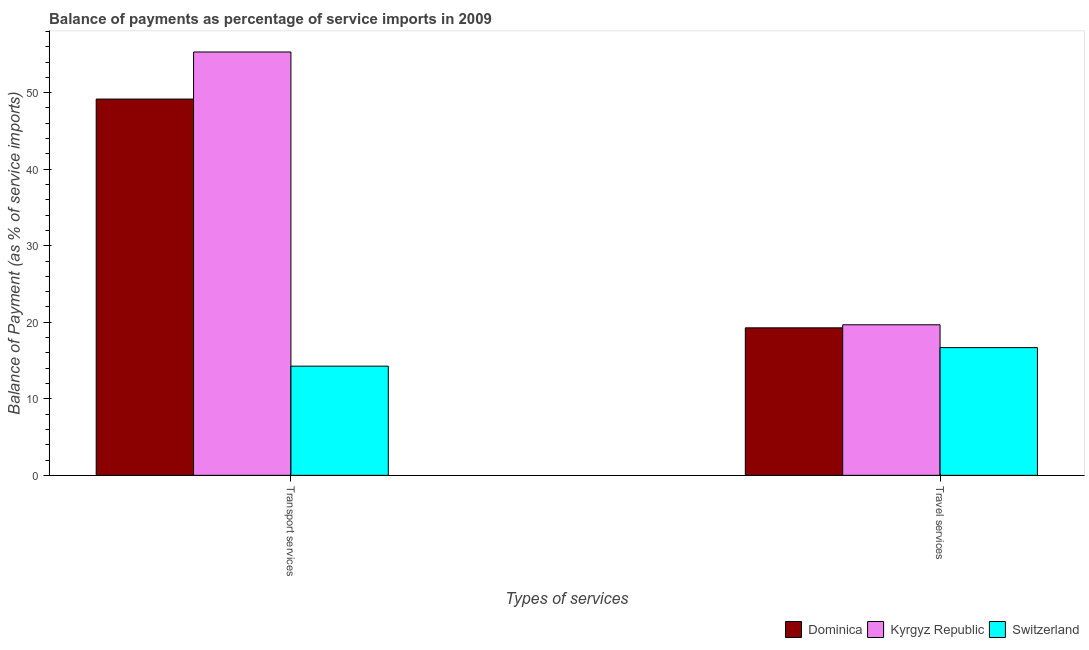How many different coloured bars are there?
Ensure brevity in your answer.  3. Are the number of bars per tick equal to the number of legend labels?
Your response must be concise. Yes. Are the number of bars on each tick of the X-axis equal?
Your response must be concise. Yes. How many bars are there on the 1st tick from the left?
Keep it short and to the point. 3. What is the label of the 1st group of bars from the left?
Make the answer very short. Transport services. What is the balance of payments of transport services in Switzerland?
Offer a very short reply. 14.27. Across all countries, what is the maximum balance of payments of transport services?
Give a very brief answer. 55.32. Across all countries, what is the minimum balance of payments of travel services?
Your answer should be very brief. 16.69. In which country was the balance of payments of travel services maximum?
Your answer should be very brief. Kyrgyz Republic. In which country was the balance of payments of transport services minimum?
Ensure brevity in your answer.  Switzerland. What is the total balance of payments of travel services in the graph?
Ensure brevity in your answer.  55.63. What is the difference between the balance of payments of travel services in Dominica and that in Switzerland?
Offer a very short reply. 2.59. What is the difference between the balance of payments of travel services in Switzerland and the balance of payments of transport services in Kyrgyz Republic?
Make the answer very short. -38.63. What is the average balance of payments of travel services per country?
Offer a terse response. 18.54. What is the difference between the balance of payments of travel services and balance of payments of transport services in Kyrgyz Republic?
Provide a succinct answer. -35.64. What is the ratio of the balance of payments of travel services in Switzerland to that in Kyrgyz Republic?
Your response must be concise. 0.85. Is the balance of payments of travel services in Kyrgyz Republic less than that in Dominica?
Your answer should be very brief. No. What does the 3rd bar from the left in Transport services represents?
Ensure brevity in your answer.  Switzerland. What does the 1st bar from the right in Travel services represents?
Ensure brevity in your answer.  Switzerland. How many bars are there?
Offer a very short reply. 6. Are all the bars in the graph horizontal?
Ensure brevity in your answer.  No. How many countries are there in the graph?
Your answer should be compact. 3. Does the graph contain grids?
Provide a short and direct response. No. What is the title of the graph?
Keep it short and to the point. Balance of payments as percentage of service imports in 2009. What is the label or title of the X-axis?
Offer a very short reply. Types of services. What is the label or title of the Y-axis?
Provide a short and direct response. Balance of Payment (as % of service imports). What is the Balance of Payment (as % of service imports) in Dominica in Transport services?
Offer a very short reply. 49.17. What is the Balance of Payment (as % of service imports) in Kyrgyz Republic in Transport services?
Your answer should be very brief. 55.32. What is the Balance of Payment (as % of service imports) in Switzerland in Transport services?
Keep it short and to the point. 14.27. What is the Balance of Payment (as % of service imports) in Dominica in Travel services?
Give a very brief answer. 19.27. What is the Balance of Payment (as % of service imports) in Kyrgyz Republic in Travel services?
Offer a very short reply. 19.67. What is the Balance of Payment (as % of service imports) of Switzerland in Travel services?
Your answer should be very brief. 16.69. Across all Types of services, what is the maximum Balance of Payment (as % of service imports) of Dominica?
Offer a terse response. 49.17. Across all Types of services, what is the maximum Balance of Payment (as % of service imports) of Kyrgyz Republic?
Offer a terse response. 55.32. Across all Types of services, what is the maximum Balance of Payment (as % of service imports) in Switzerland?
Offer a terse response. 16.69. Across all Types of services, what is the minimum Balance of Payment (as % of service imports) of Dominica?
Offer a very short reply. 19.27. Across all Types of services, what is the minimum Balance of Payment (as % of service imports) of Kyrgyz Republic?
Give a very brief answer. 19.67. Across all Types of services, what is the minimum Balance of Payment (as % of service imports) in Switzerland?
Give a very brief answer. 14.27. What is the total Balance of Payment (as % of service imports) of Dominica in the graph?
Give a very brief answer. 68.44. What is the total Balance of Payment (as % of service imports) in Kyrgyz Republic in the graph?
Offer a terse response. 74.99. What is the total Balance of Payment (as % of service imports) in Switzerland in the graph?
Your response must be concise. 30.95. What is the difference between the Balance of Payment (as % of service imports) in Dominica in Transport services and that in Travel services?
Your response must be concise. 29.89. What is the difference between the Balance of Payment (as % of service imports) of Kyrgyz Republic in Transport services and that in Travel services?
Provide a succinct answer. 35.64. What is the difference between the Balance of Payment (as % of service imports) in Switzerland in Transport services and that in Travel services?
Make the answer very short. -2.42. What is the difference between the Balance of Payment (as % of service imports) of Dominica in Transport services and the Balance of Payment (as % of service imports) of Kyrgyz Republic in Travel services?
Ensure brevity in your answer.  29.49. What is the difference between the Balance of Payment (as % of service imports) in Dominica in Transport services and the Balance of Payment (as % of service imports) in Switzerland in Travel services?
Give a very brief answer. 32.48. What is the difference between the Balance of Payment (as % of service imports) in Kyrgyz Republic in Transport services and the Balance of Payment (as % of service imports) in Switzerland in Travel services?
Your response must be concise. 38.63. What is the average Balance of Payment (as % of service imports) of Dominica per Types of services?
Offer a very short reply. 34.22. What is the average Balance of Payment (as % of service imports) in Kyrgyz Republic per Types of services?
Give a very brief answer. 37.49. What is the average Balance of Payment (as % of service imports) of Switzerland per Types of services?
Give a very brief answer. 15.48. What is the difference between the Balance of Payment (as % of service imports) in Dominica and Balance of Payment (as % of service imports) in Kyrgyz Republic in Transport services?
Your answer should be very brief. -6.15. What is the difference between the Balance of Payment (as % of service imports) of Dominica and Balance of Payment (as % of service imports) of Switzerland in Transport services?
Keep it short and to the point. 34.9. What is the difference between the Balance of Payment (as % of service imports) of Kyrgyz Republic and Balance of Payment (as % of service imports) of Switzerland in Transport services?
Give a very brief answer. 41.05. What is the difference between the Balance of Payment (as % of service imports) in Dominica and Balance of Payment (as % of service imports) in Kyrgyz Republic in Travel services?
Offer a very short reply. -0.4. What is the difference between the Balance of Payment (as % of service imports) of Dominica and Balance of Payment (as % of service imports) of Switzerland in Travel services?
Keep it short and to the point. 2.59. What is the difference between the Balance of Payment (as % of service imports) in Kyrgyz Republic and Balance of Payment (as % of service imports) in Switzerland in Travel services?
Keep it short and to the point. 2.99. What is the ratio of the Balance of Payment (as % of service imports) of Dominica in Transport services to that in Travel services?
Your answer should be compact. 2.55. What is the ratio of the Balance of Payment (as % of service imports) in Kyrgyz Republic in Transport services to that in Travel services?
Provide a short and direct response. 2.81. What is the ratio of the Balance of Payment (as % of service imports) of Switzerland in Transport services to that in Travel services?
Keep it short and to the point. 0.85. What is the difference between the highest and the second highest Balance of Payment (as % of service imports) of Dominica?
Provide a succinct answer. 29.89. What is the difference between the highest and the second highest Balance of Payment (as % of service imports) in Kyrgyz Republic?
Offer a terse response. 35.64. What is the difference between the highest and the second highest Balance of Payment (as % of service imports) in Switzerland?
Your response must be concise. 2.42. What is the difference between the highest and the lowest Balance of Payment (as % of service imports) in Dominica?
Keep it short and to the point. 29.89. What is the difference between the highest and the lowest Balance of Payment (as % of service imports) of Kyrgyz Republic?
Offer a terse response. 35.64. What is the difference between the highest and the lowest Balance of Payment (as % of service imports) in Switzerland?
Offer a terse response. 2.42. 